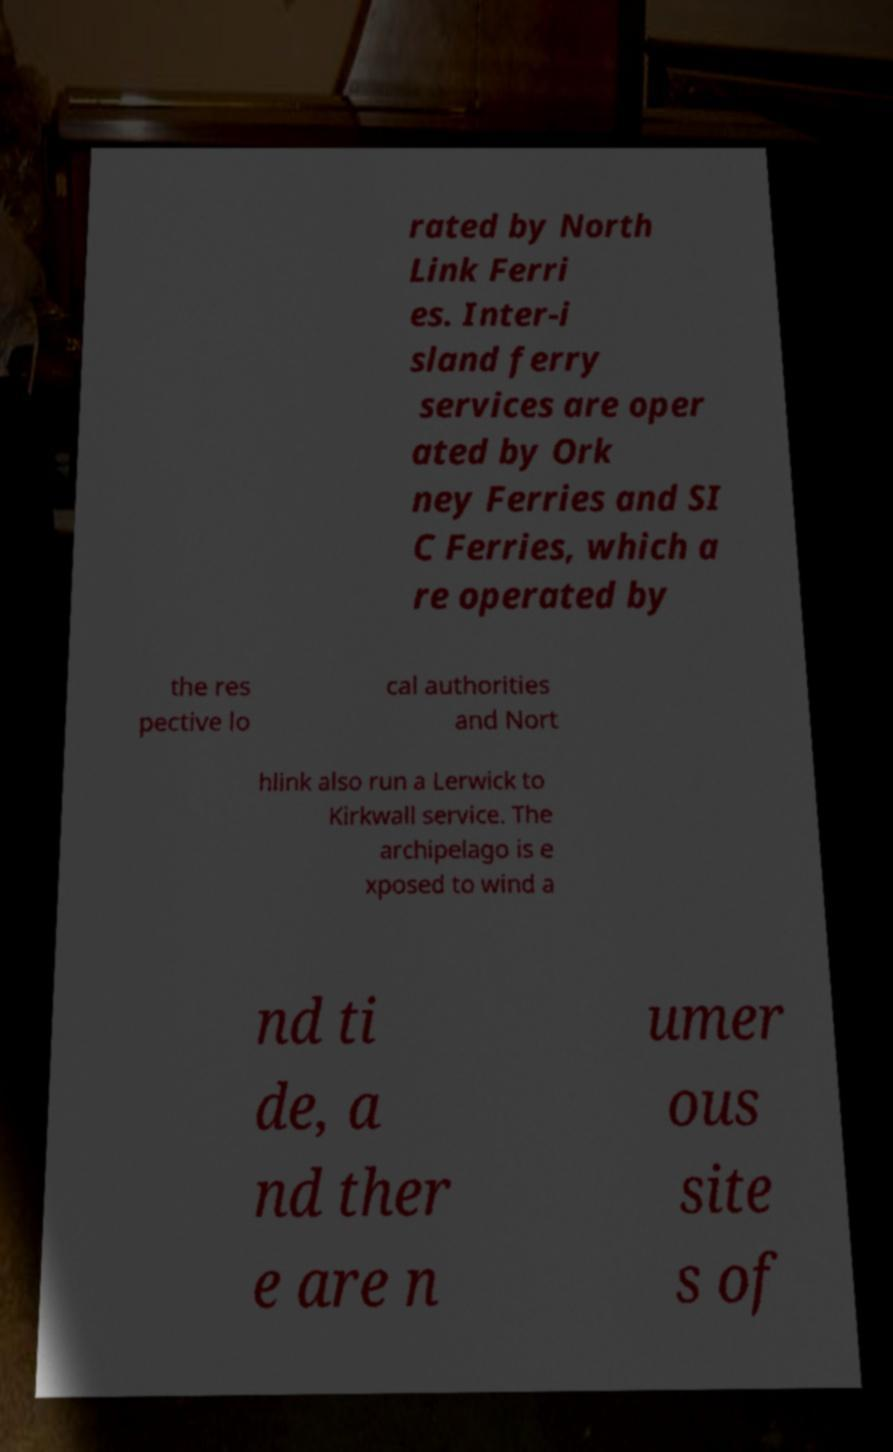Can you accurately transcribe the text from the provided image for me? rated by North Link Ferri es. Inter-i sland ferry services are oper ated by Ork ney Ferries and SI C Ferries, which a re operated by the res pective lo cal authorities and Nort hlink also run a Lerwick to Kirkwall service. The archipelago is e xposed to wind a nd ti de, a nd ther e are n umer ous site s of 